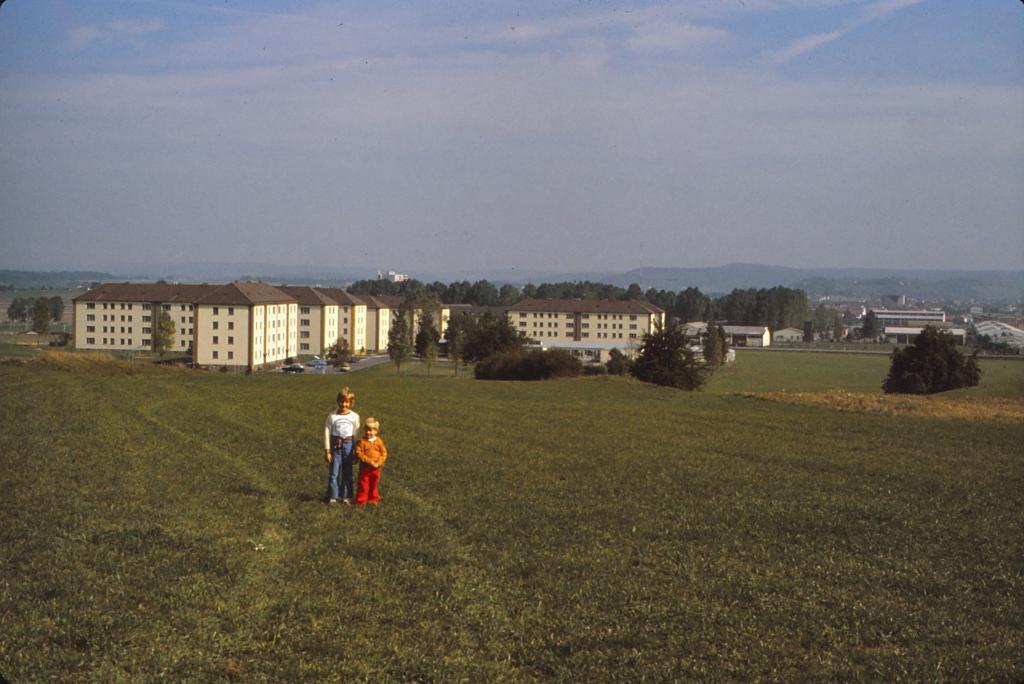How many kids are present in the image? There are two kids standing in the image. What are the kids wearing? The kids are wearing clothes. What can be seen in the middle of the image? There are buildings and trees in the middle of the image. What is visible in the background of the image? The sky is visible in the background of the image. How many trucks are parked next to the kids in the image? There are no trucks visible in the image; it only features two kids, buildings, trees, and the sky. What type of cakes are the kids holding in the image? There are no cakes present in the image; the kids are not holding any objects. 